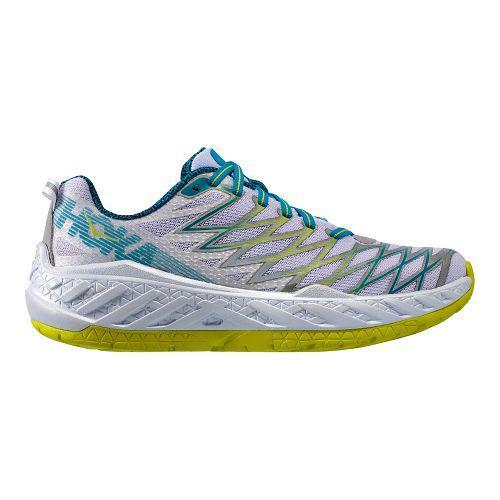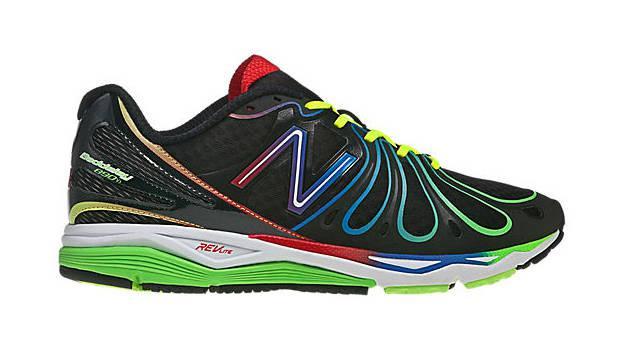The first image is the image on the left, the second image is the image on the right. Evaluate the accuracy of this statement regarding the images: "Both shoes have the same logo across the side.". Is it true? Answer yes or no. No. 